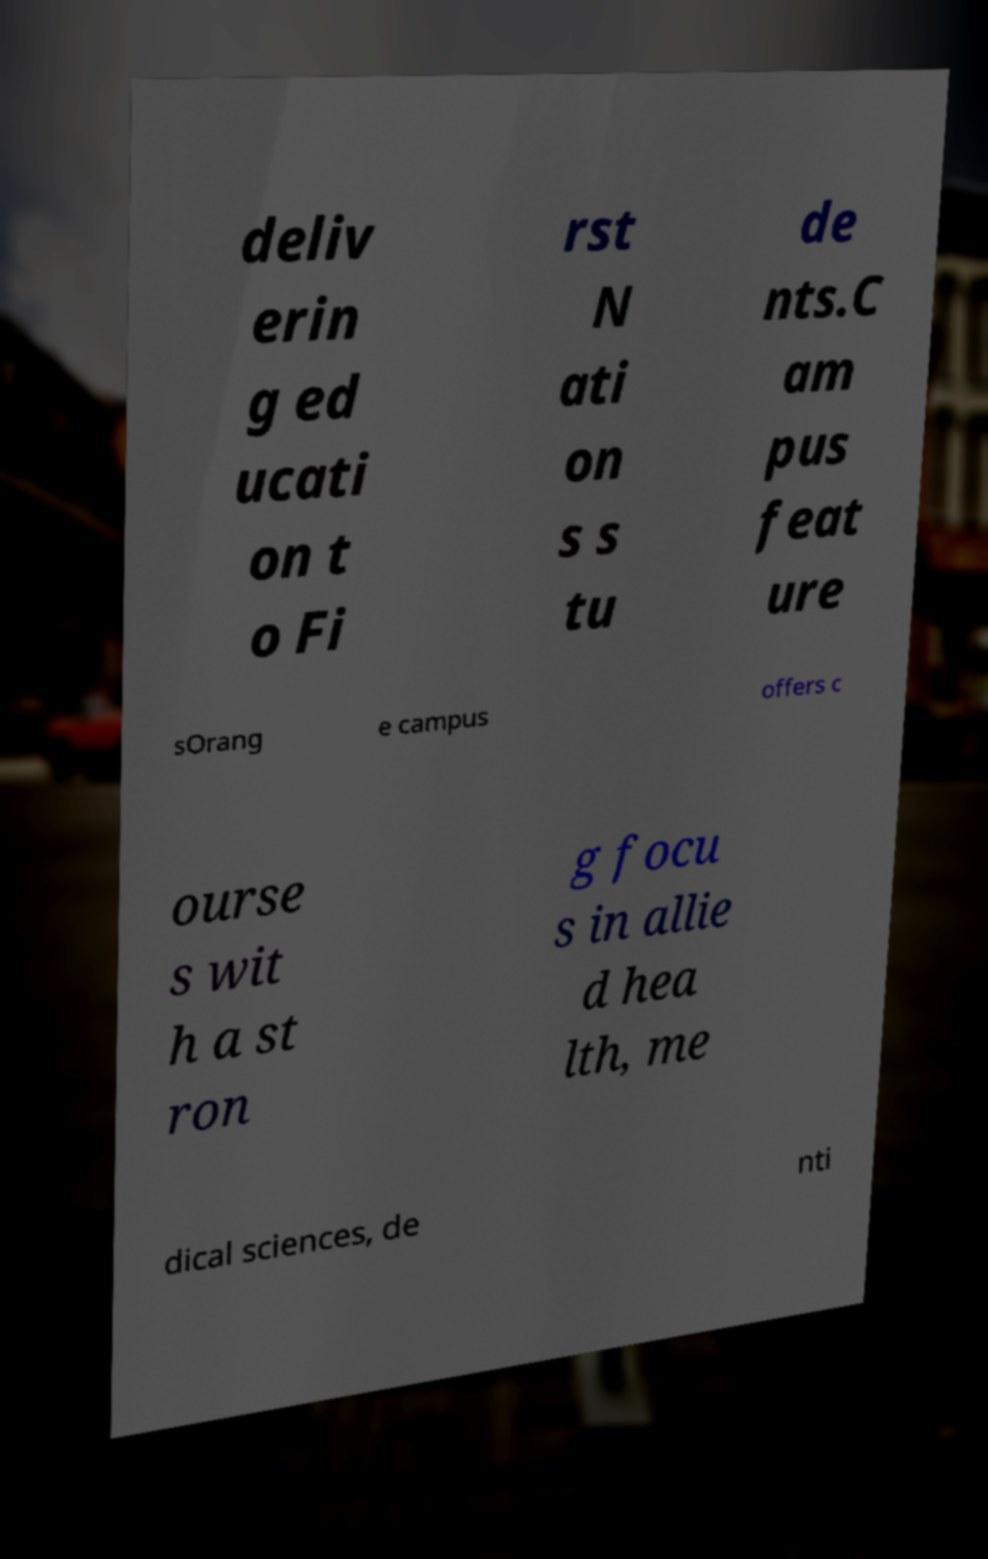What messages or text are displayed in this image? I need them in a readable, typed format. deliv erin g ed ucati on t o Fi rst N ati on s s tu de nts.C am pus feat ure sOrang e campus offers c ourse s wit h a st ron g focu s in allie d hea lth, me dical sciences, de nti 